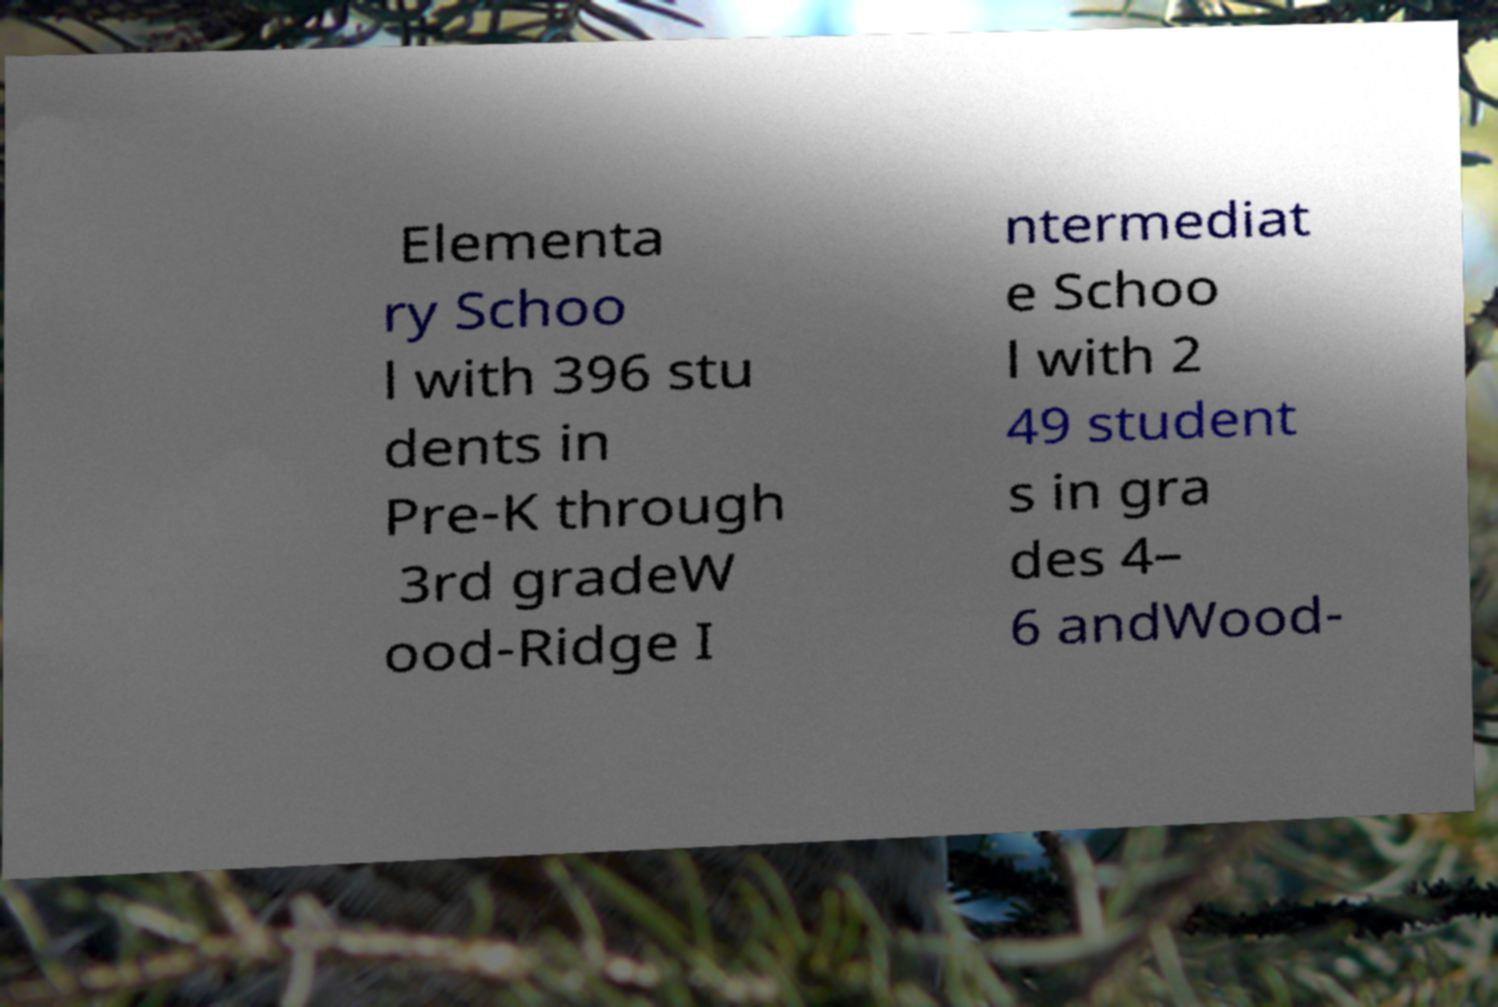Please read and relay the text visible in this image. What does it say? Elementa ry Schoo l with 396 stu dents in Pre-K through 3rd gradeW ood-Ridge I ntermediat e Schoo l with 2 49 student s in gra des 4– 6 andWood- 